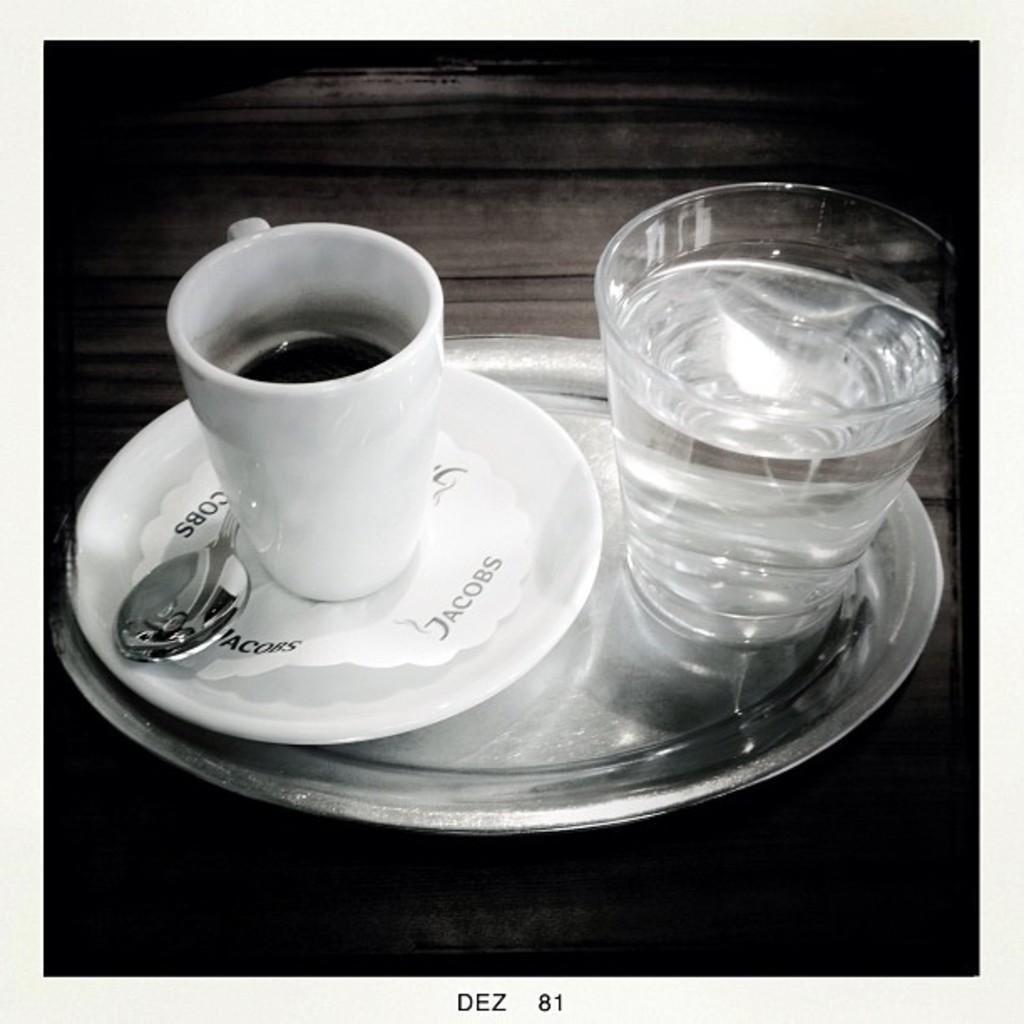Please provide a concise description of this image. In this picture we can see a cup and a glass with drinks in it, here we can see a saucer, spoon and these all are in the plate and this plate is on the platform. 